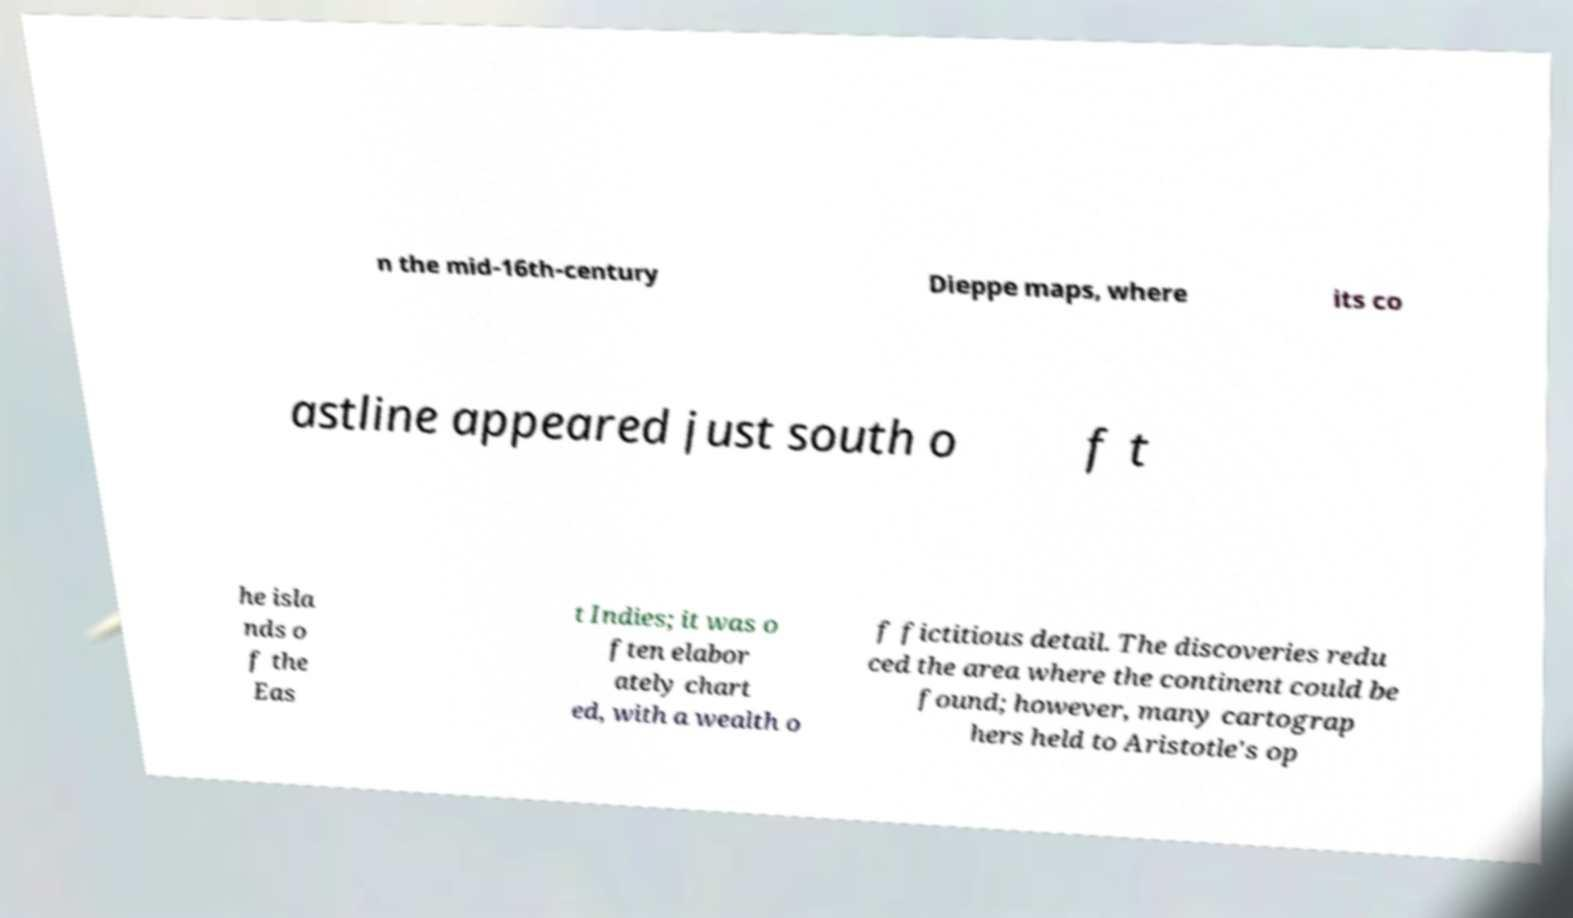Can you accurately transcribe the text from the provided image for me? n the mid-16th-century Dieppe maps, where its co astline appeared just south o f t he isla nds o f the Eas t Indies; it was o ften elabor ately chart ed, with a wealth o f fictitious detail. The discoveries redu ced the area where the continent could be found; however, many cartograp hers held to Aristotle's op 